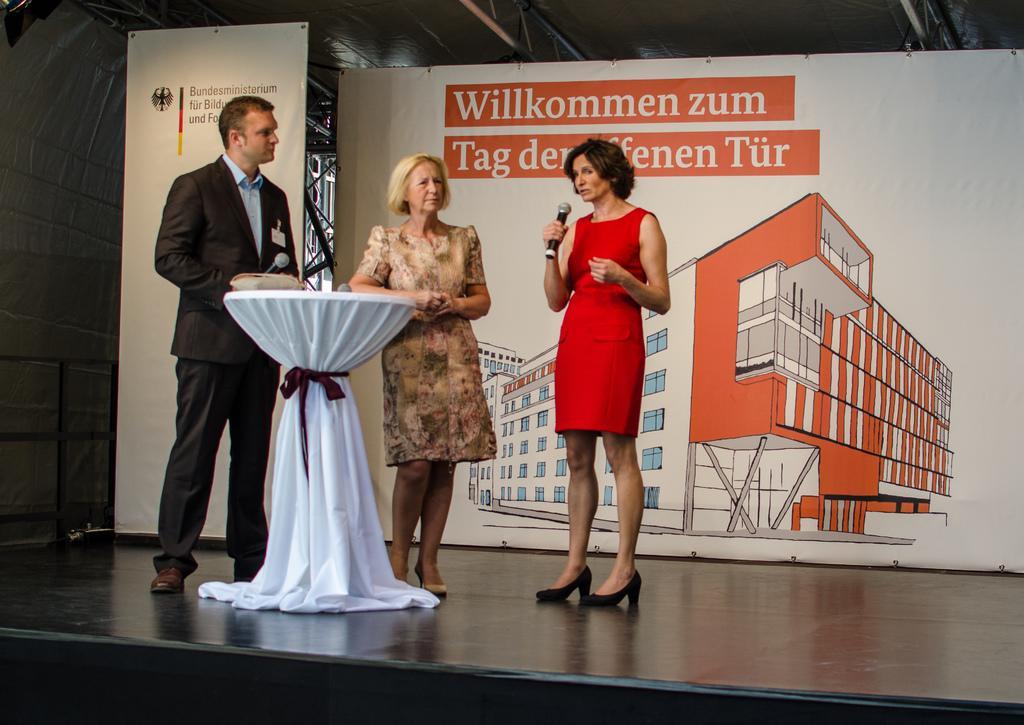In one or two sentences, can you explain what this image depicts? In this image I can see three people with different color dresses. I can see two people holding the mics. There is a stand covered with white color cloth and it is in-front of these people. In the background I can see the banner. 